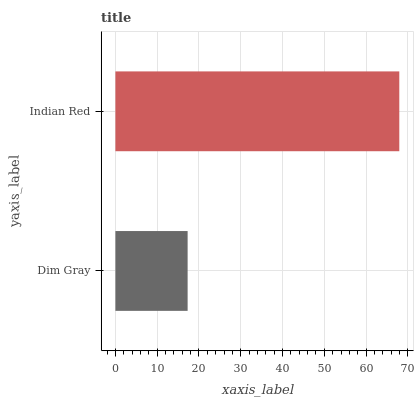Is Dim Gray the minimum?
Answer yes or no. Yes. Is Indian Red the maximum?
Answer yes or no. Yes. Is Indian Red the minimum?
Answer yes or no. No. Is Indian Red greater than Dim Gray?
Answer yes or no. Yes. Is Dim Gray less than Indian Red?
Answer yes or no. Yes. Is Dim Gray greater than Indian Red?
Answer yes or no. No. Is Indian Red less than Dim Gray?
Answer yes or no. No. Is Indian Red the high median?
Answer yes or no. Yes. Is Dim Gray the low median?
Answer yes or no. Yes. Is Dim Gray the high median?
Answer yes or no. No. Is Indian Red the low median?
Answer yes or no. No. 